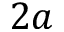Convert formula to latex. <formula><loc_0><loc_0><loc_500><loc_500>2 a</formula> 